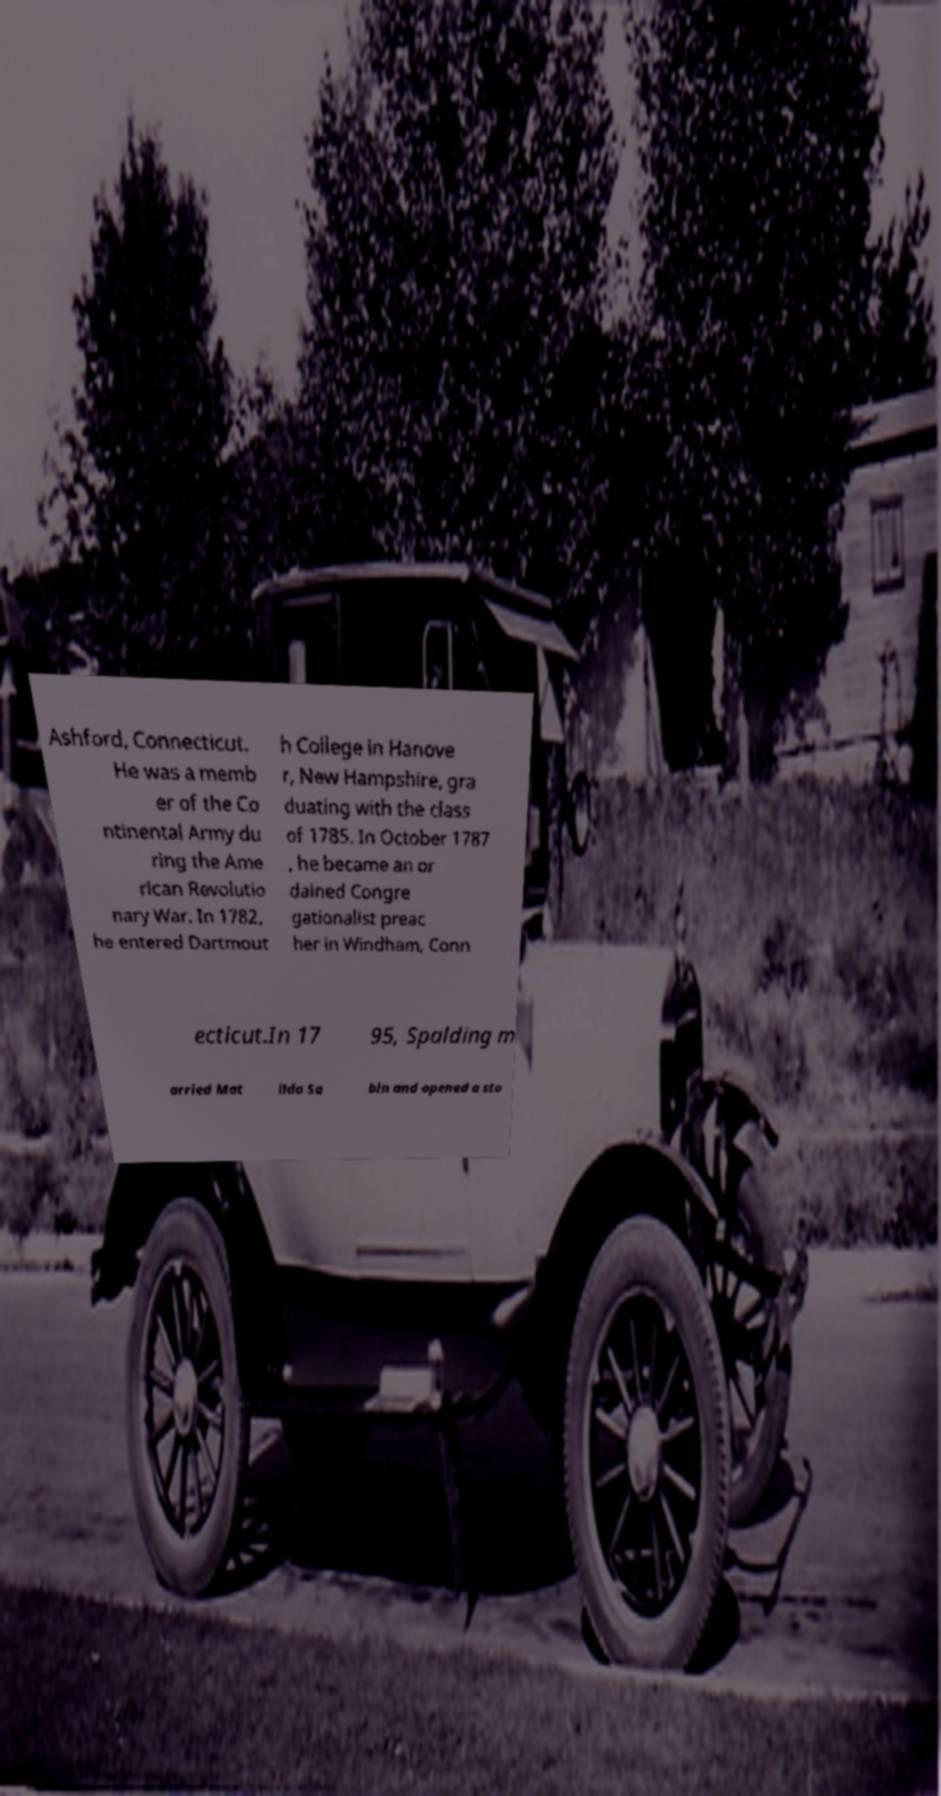I need the written content from this picture converted into text. Can you do that? Ashford, Connecticut. He was a memb er of the Co ntinental Army du ring the Ame rican Revolutio nary War. In 1782, he entered Dartmout h College in Hanove r, New Hampshire, gra duating with the class of 1785. In October 1787 , he became an or dained Congre gationalist preac her in Windham, Conn ecticut.In 17 95, Spalding m arried Mat ilda Sa bin and opened a sto 